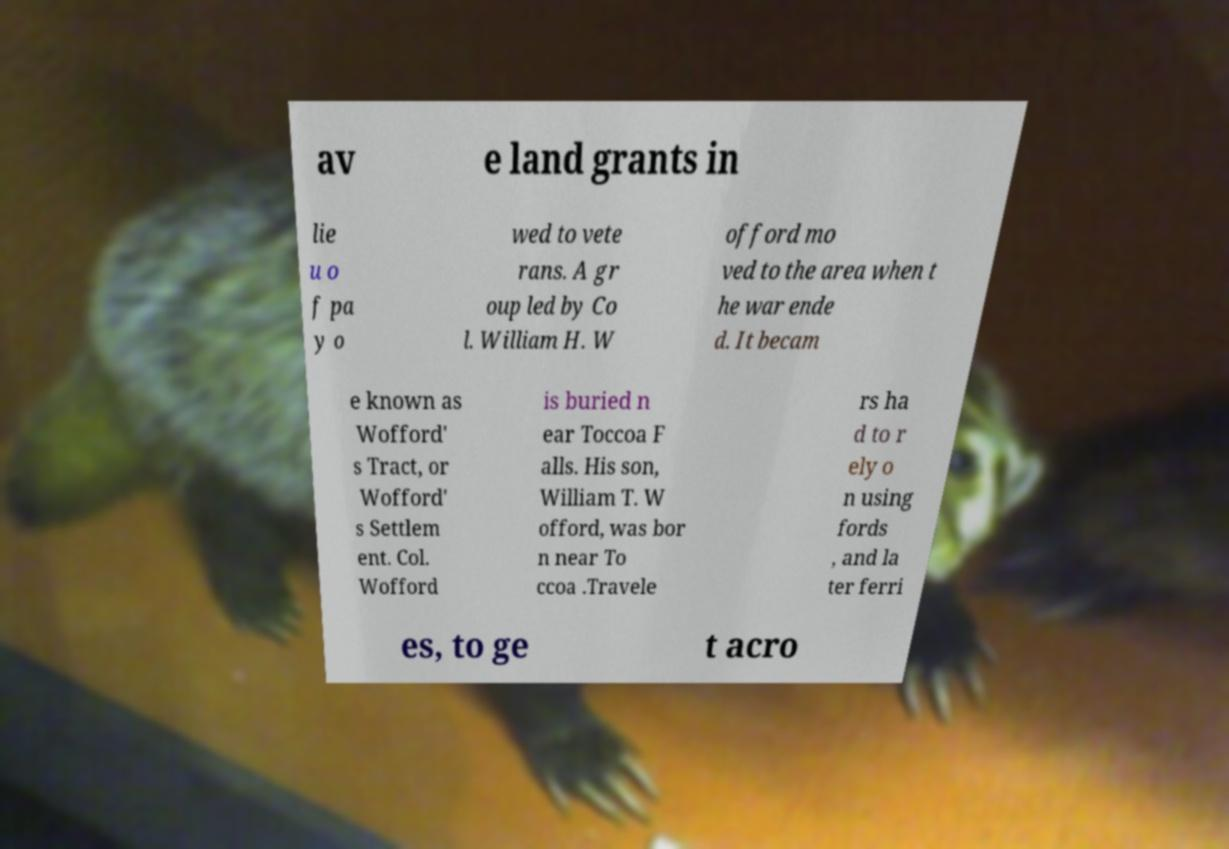Could you extract and type out the text from this image? av e land grants in lie u o f pa y o wed to vete rans. A gr oup led by Co l. William H. W offord mo ved to the area when t he war ende d. It becam e known as Wofford' s Tract, or Wofford' s Settlem ent. Col. Wofford is buried n ear Toccoa F alls. His son, William T. W offord, was bor n near To ccoa .Travele rs ha d to r ely o n using fords , and la ter ferri es, to ge t acro 